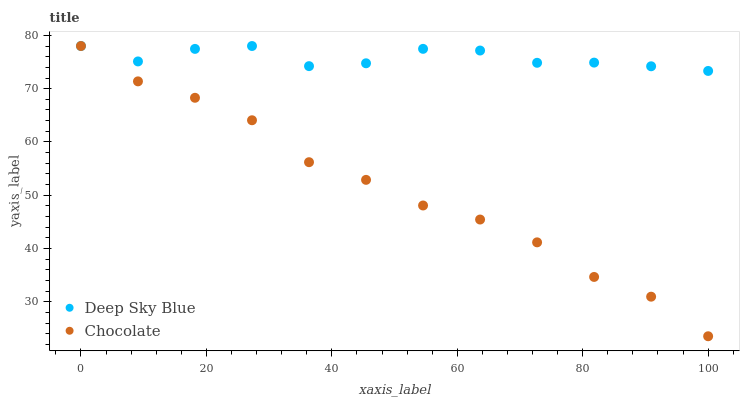Does Chocolate have the minimum area under the curve?
Answer yes or no. Yes. Does Deep Sky Blue have the maximum area under the curve?
Answer yes or no. Yes. Does Chocolate have the maximum area under the curve?
Answer yes or no. No. Is Deep Sky Blue the smoothest?
Answer yes or no. Yes. Is Chocolate the roughest?
Answer yes or no. Yes. Is Chocolate the smoothest?
Answer yes or no. No. Does Chocolate have the lowest value?
Answer yes or no. Yes. Does Chocolate have the highest value?
Answer yes or no. Yes. Does Deep Sky Blue intersect Chocolate?
Answer yes or no. Yes. Is Deep Sky Blue less than Chocolate?
Answer yes or no. No. Is Deep Sky Blue greater than Chocolate?
Answer yes or no. No. 